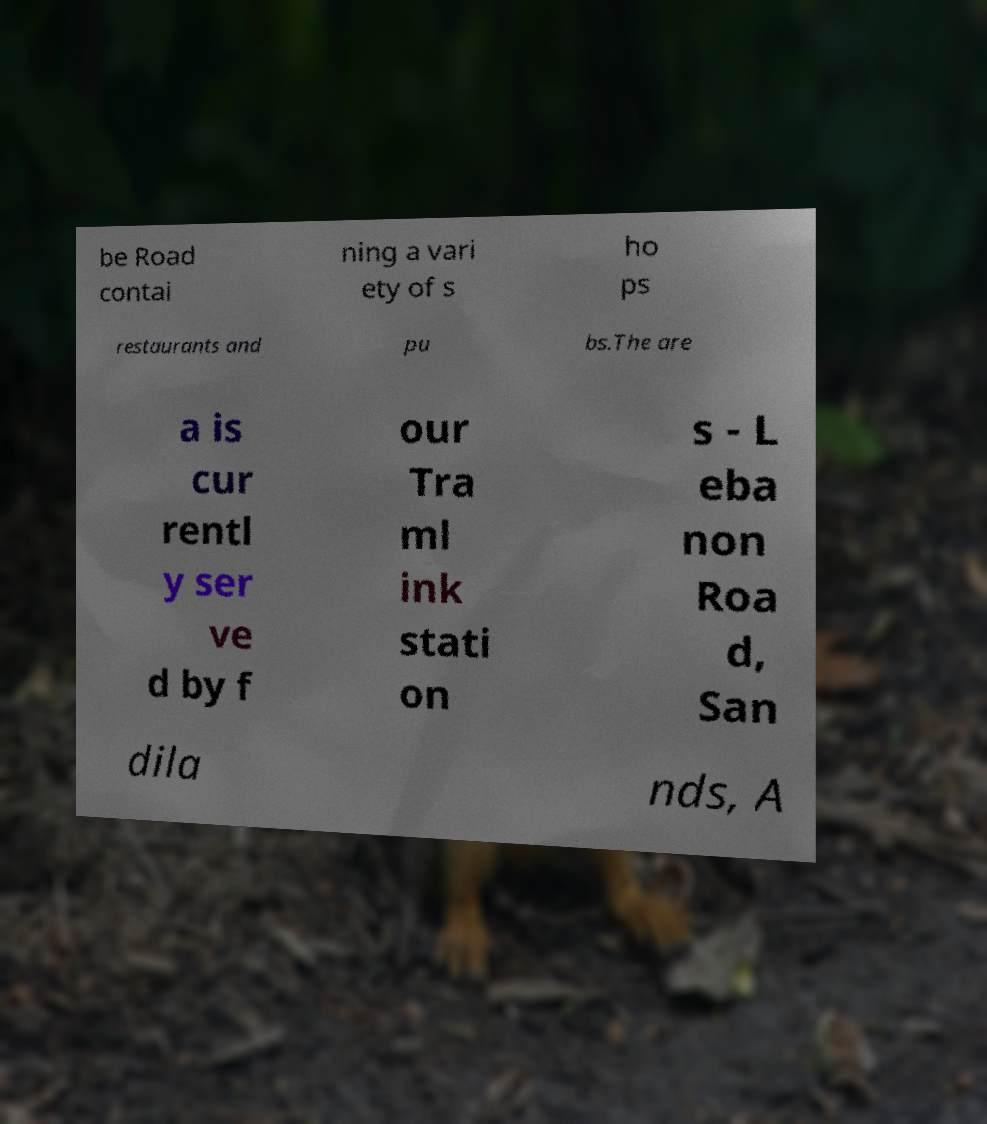What messages or text are displayed in this image? I need them in a readable, typed format. be Road contai ning a vari ety of s ho ps restaurants and pu bs.The are a is cur rentl y ser ve d by f our Tra ml ink stati on s - L eba non Roa d, San dila nds, A 